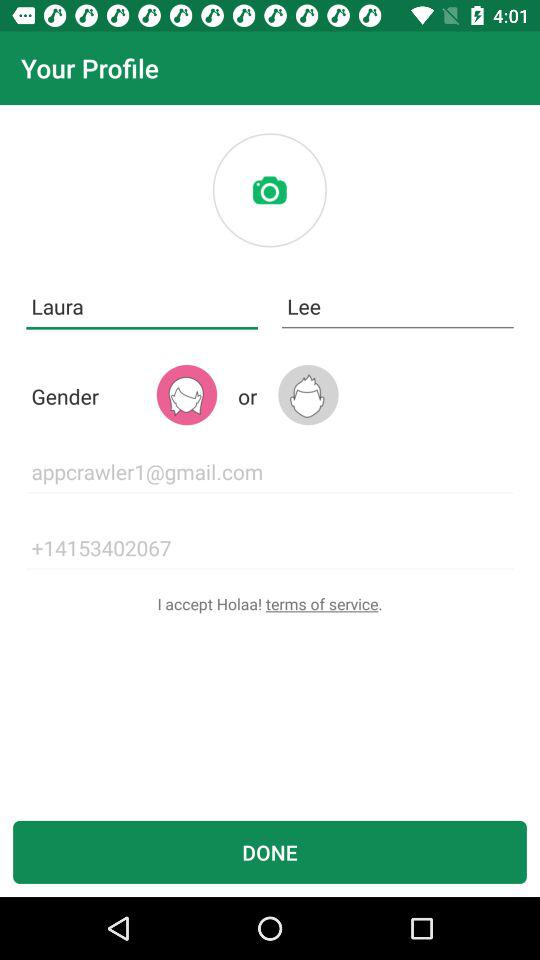What is the email ID of Laura? The email ID is appcrawler1@gmail.com. 